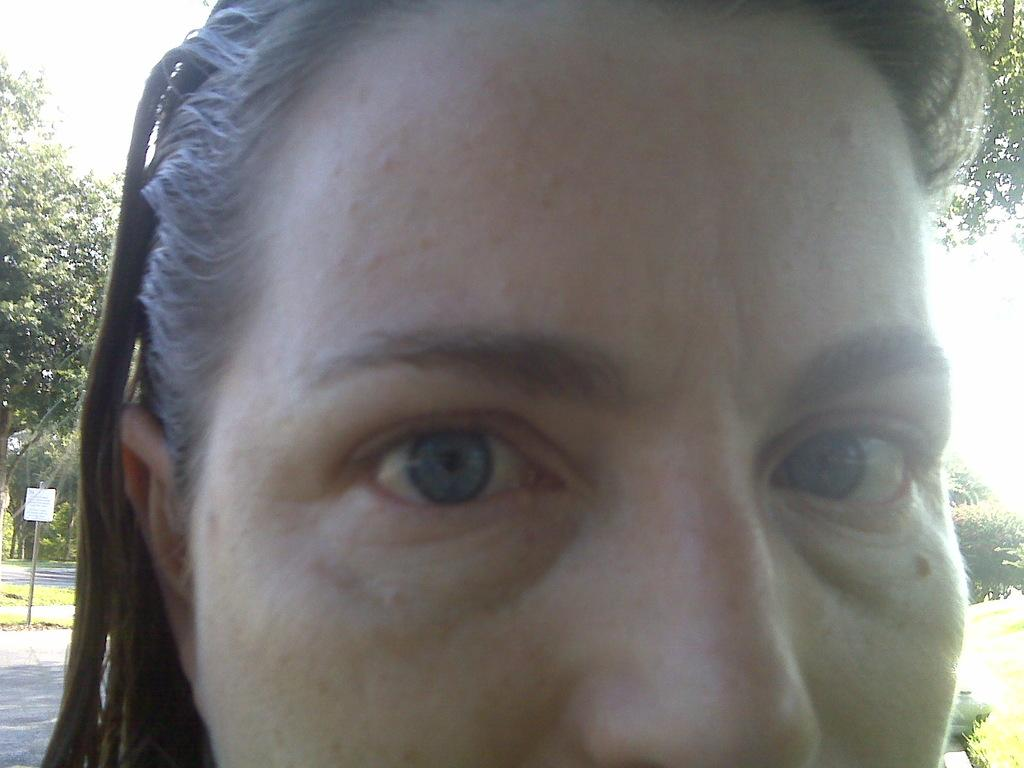What is the main subject of the image? There is a person's face in the center of the image. What can be seen in the background of the image? The sky, clouds, trees, a road, a pole, a sign board, and a few other objects are visible in the background of the image. What flavor of ice cream is the person holding in the image? There is no ice cream present in the image; it only features a person's face and the background elements. What type of roof can be seen on the building in the image? There is no building or roof visible in the image; it only features a person's face and the background elements. 